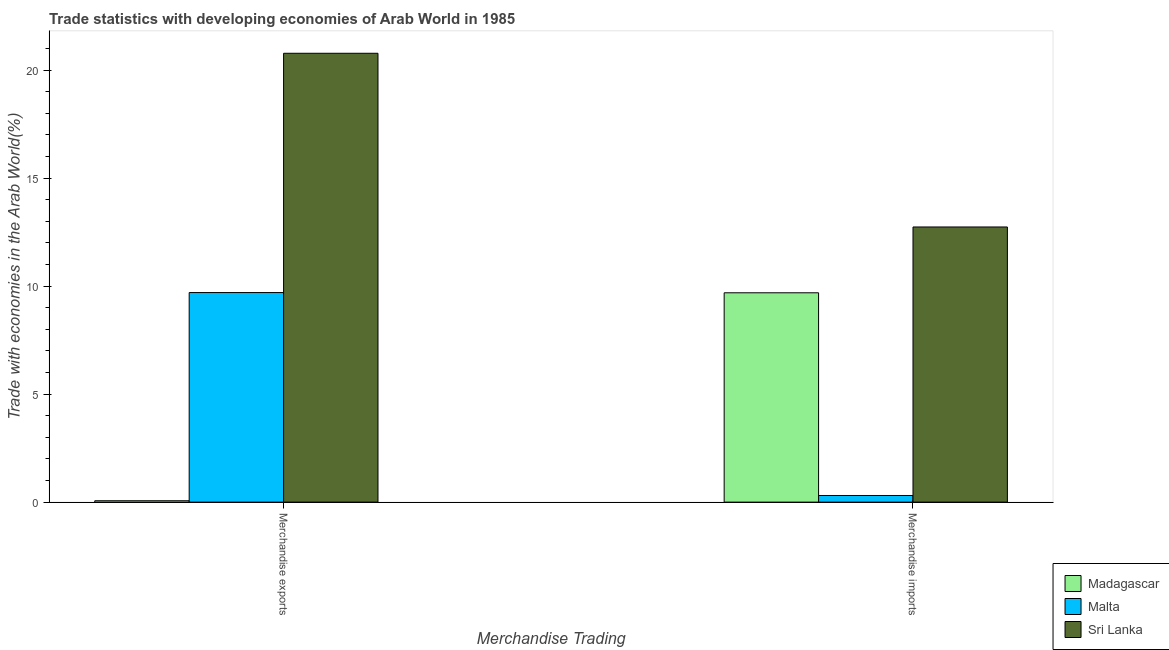How many different coloured bars are there?
Make the answer very short. 3. Are the number of bars on each tick of the X-axis equal?
Keep it short and to the point. Yes. How many bars are there on the 2nd tick from the right?
Ensure brevity in your answer.  3. What is the label of the 1st group of bars from the left?
Provide a succinct answer. Merchandise exports. What is the merchandise exports in Sri Lanka?
Make the answer very short. 20.78. Across all countries, what is the maximum merchandise imports?
Provide a succinct answer. 12.74. Across all countries, what is the minimum merchandise exports?
Provide a short and direct response. 0.06. In which country was the merchandise imports maximum?
Ensure brevity in your answer.  Sri Lanka. In which country was the merchandise imports minimum?
Provide a short and direct response. Malta. What is the total merchandise imports in the graph?
Offer a terse response. 22.74. What is the difference between the merchandise imports in Madagascar and that in Malta?
Offer a very short reply. 9.38. What is the difference between the merchandise imports in Sri Lanka and the merchandise exports in Malta?
Your answer should be very brief. 3.04. What is the average merchandise imports per country?
Make the answer very short. 7.58. What is the difference between the merchandise exports and merchandise imports in Madagascar?
Your answer should be compact. -9.63. What is the ratio of the merchandise exports in Sri Lanka to that in Malta?
Ensure brevity in your answer.  2.14. Is the merchandise exports in Malta less than that in Madagascar?
Keep it short and to the point. No. What does the 1st bar from the left in Merchandise exports represents?
Provide a succinct answer. Madagascar. What does the 2nd bar from the right in Merchandise imports represents?
Keep it short and to the point. Malta. How many bars are there?
Offer a very short reply. 6. Are all the bars in the graph horizontal?
Provide a succinct answer. No. How many countries are there in the graph?
Provide a succinct answer. 3. Where does the legend appear in the graph?
Your response must be concise. Bottom right. How many legend labels are there?
Ensure brevity in your answer.  3. What is the title of the graph?
Your response must be concise. Trade statistics with developing economies of Arab World in 1985. Does "Netherlands" appear as one of the legend labels in the graph?
Your response must be concise. No. What is the label or title of the X-axis?
Give a very brief answer. Merchandise Trading. What is the label or title of the Y-axis?
Offer a very short reply. Trade with economies in the Arab World(%). What is the Trade with economies in the Arab World(%) in Madagascar in Merchandise exports?
Make the answer very short. 0.06. What is the Trade with economies in the Arab World(%) in Malta in Merchandise exports?
Keep it short and to the point. 9.7. What is the Trade with economies in the Arab World(%) in Sri Lanka in Merchandise exports?
Make the answer very short. 20.78. What is the Trade with economies in the Arab World(%) in Madagascar in Merchandise imports?
Your answer should be very brief. 9.69. What is the Trade with economies in the Arab World(%) in Malta in Merchandise imports?
Give a very brief answer. 0.31. What is the Trade with economies in the Arab World(%) in Sri Lanka in Merchandise imports?
Provide a short and direct response. 12.74. Across all Merchandise Trading, what is the maximum Trade with economies in the Arab World(%) in Madagascar?
Your answer should be compact. 9.69. Across all Merchandise Trading, what is the maximum Trade with economies in the Arab World(%) in Malta?
Provide a short and direct response. 9.7. Across all Merchandise Trading, what is the maximum Trade with economies in the Arab World(%) of Sri Lanka?
Give a very brief answer. 20.78. Across all Merchandise Trading, what is the minimum Trade with economies in the Arab World(%) of Madagascar?
Keep it short and to the point. 0.06. Across all Merchandise Trading, what is the minimum Trade with economies in the Arab World(%) of Malta?
Offer a very short reply. 0.31. Across all Merchandise Trading, what is the minimum Trade with economies in the Arab World(%) in Sri Lanka?
Keep it short and to the point. 12.74. What is the total Trade with economies in the Arab World(%) in Madagascar in the graph?
Your answer should be compact. 9.75. What is the total Trade with economies in the Arab World(%) of Malta in the graph?
Provide a short and direct response. 10.01. What is the total Trade with economies in the Arab World(%) in Sri Lanka in the graph?
Keep it short and to the point. 33.52. What is the difference between the Trade with economies in the Arab World(%) in Madagascar in Merchandise exports and that in Merchandise imports?
Provide a short and direct response. -9.63. What is the difference between the Trade with economies in the Arab World(%) of Malta in Merchandise exports and that in Merchandise imports?
Make the answer very short. 9.39. What is the difference between the Trade with economies in the Arab World(%) in Sri Lanka in Merchandise exports and that in Merchandise imports?
Provide a succinct answer. 8.04. What is the difference between the Trade with economies in the Arab World(%) of Madagascar in Merchandise exports and the Trade with economies in the Arab World(%) of Malta in Merchandise imports?
Your answer should be compact. -0.24. What is the difference between the Trade with economies in the Arab World(%) in Madagascar in Merchandise exports and the Trade with economies in the Arab World(%) in Sri Lanka in Merchandise imports?
Give a very brief answer. -12.67. What is the difference between the Trade with economies in the Arab World(%) of Malta in Merchandise exports and the Trade with economies in the Arab World(%) of Sri Lanka in Merchandise imports?
Your answer should be very brief. -3.04. What is the average Trade with economies in the Arab World(%) of Madagascar per Merchandise Trading?
Your answer should be very brief. 4.88. What is the average Trade with economies in the Arab World(%) of Malta per Merchandise Trading?
Ensure brevity in your answer.  5. What is the average Trade with economies in the Arab World(%) in Sri Lanka per Merchandise Trading?
Provide a short and direct response. 16.76. What is the difference between the Trade with economies in the Arab World(%) in Madagascar and Trade with economies in the Arab World(%) in Malta in Merchandise exports?
Keep it short and to the point. -9.64. What is the difference between the Trade with economies in the Arab World(%) in Madagascar and Trade with economies in the Arab World(%) in Sri Lanka in Merchandise exports?
Provide a succinct answer. -20.71. What is the difference between the Trade with economies in the Arab World(%) of Malta and Trade with economies in the Arab World(%) of Sri Lanka in Merchandise exports?
Your response must be concise. -11.08. What is the difference between the Trade with economies in the Arab World(%) in Madagascar and Trade with economies in the Arab World(%) in Malta in Merchandise imports?
Provide a succinct answer. 9.38. What is the difference between the Trade with economies in the Arab World(%) in Madagascar and Trade with economies in the Arab World(%) in Sri Lanka in Merchandise imports?
Offer a terse response. -3.05. What is the difference between the Trade with economies in the Arab World(%) in Malta and Trade with economies in the Arab World(%) in Sri Lanka in Merchandise imports?
Provide a short and direct response. -12.43. What is the ratio of the Trade with economies in the Arab World(%) of Madagascar in Merchandise exports to that in Merchandise imports?
Give a very brief answer. 0.01. What is the ratio of the Trade with economies in the Arab World(%) of Malta in Merchandise exports to that in Merchandise imports?
Your answer should be very brief. 31.63. What is the ratio of the Trade with economies in the Arab World(%) in Sri Lanka in Merchandise exports to that in Merchandise imports?
Your response must be concise. 1.63. What is the difference between the highest and the second highest Trade with economies in the Arab World(%) of Madagascar?
Give a very brief answer. 9.63. What is the difference between the highest and the second highest Trade with economies in the Arab World(%) in Malta?
Provide a succinct answer. 9.39. What is the difference between the highest and the second highest Trade with economies in the Arab World(%) in Sri Lanka?
Offer a terse response. 8.04. What is the difference between the highest and the lowest Trade with economies in the Arab World(%) in Madagascar?
Your answer should be compact. 9.63. What is the difference between the highest and the lowest Trade with economies in the Arab World(%) of Malta?
Offer a terse response. 9.39. What is the difference between the highest and the lowest Trade with economies in the Arab World(%) of Sri Lanka?
Make the answer very short. 8.04. 